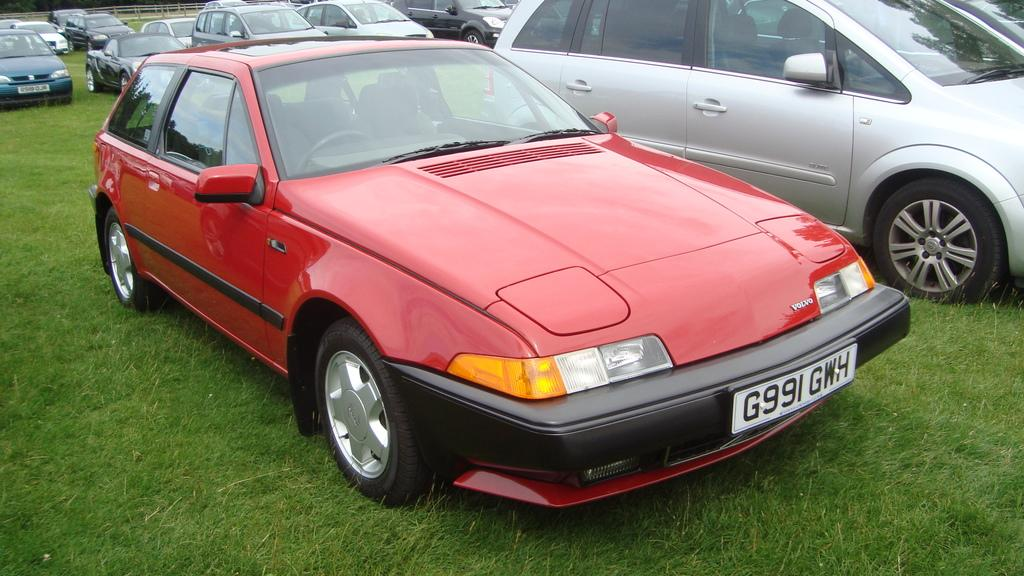What type of vehicles can be seen in the image? There are cars in the image. What is the surface at the bottom of the image made of? There is grass on the surface at the bottom of the image. What can be seen in the background of the image? There is a metal fence in the background of the image. Who is the manager of the kite flying in the image? There is no kite present in the image, so there is no manager for any kite flying. 